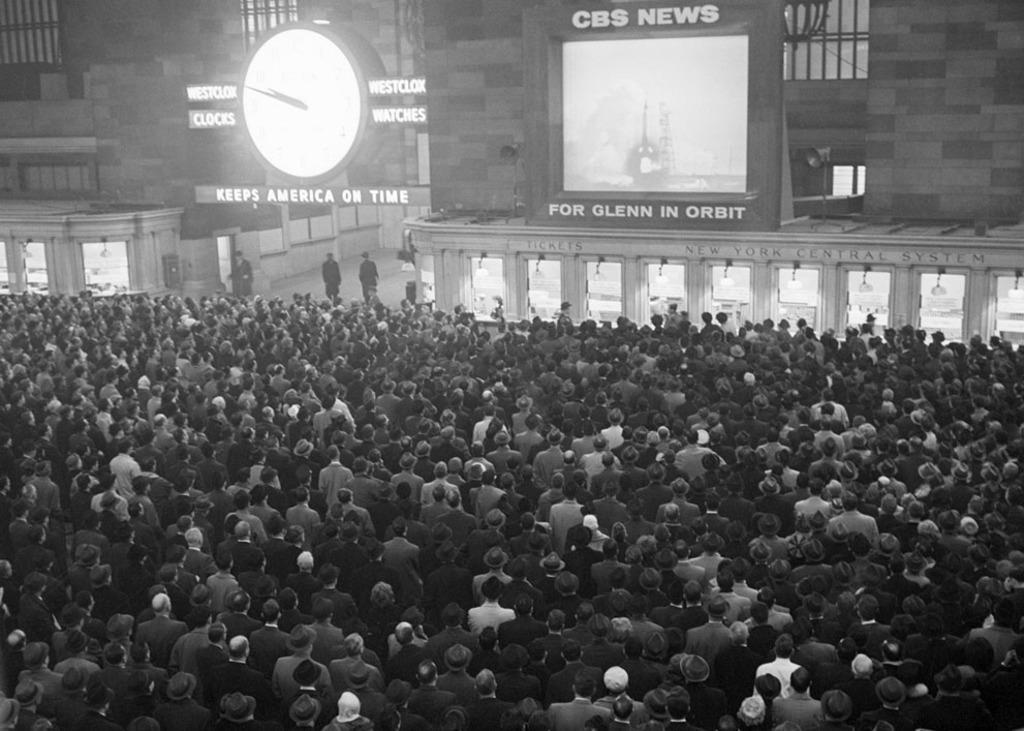Please provide a concise description of this image. In this image, we can see some people standing and they are watching the news, at the left side there is a white color clock. 